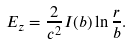<formula> <loc_0><loc_0><loc_500><loc_500>E _ { z } = \frac { 2 } { c ^ { 2 } } I ( b ) \ln \frac { r } { b } .</formula> 